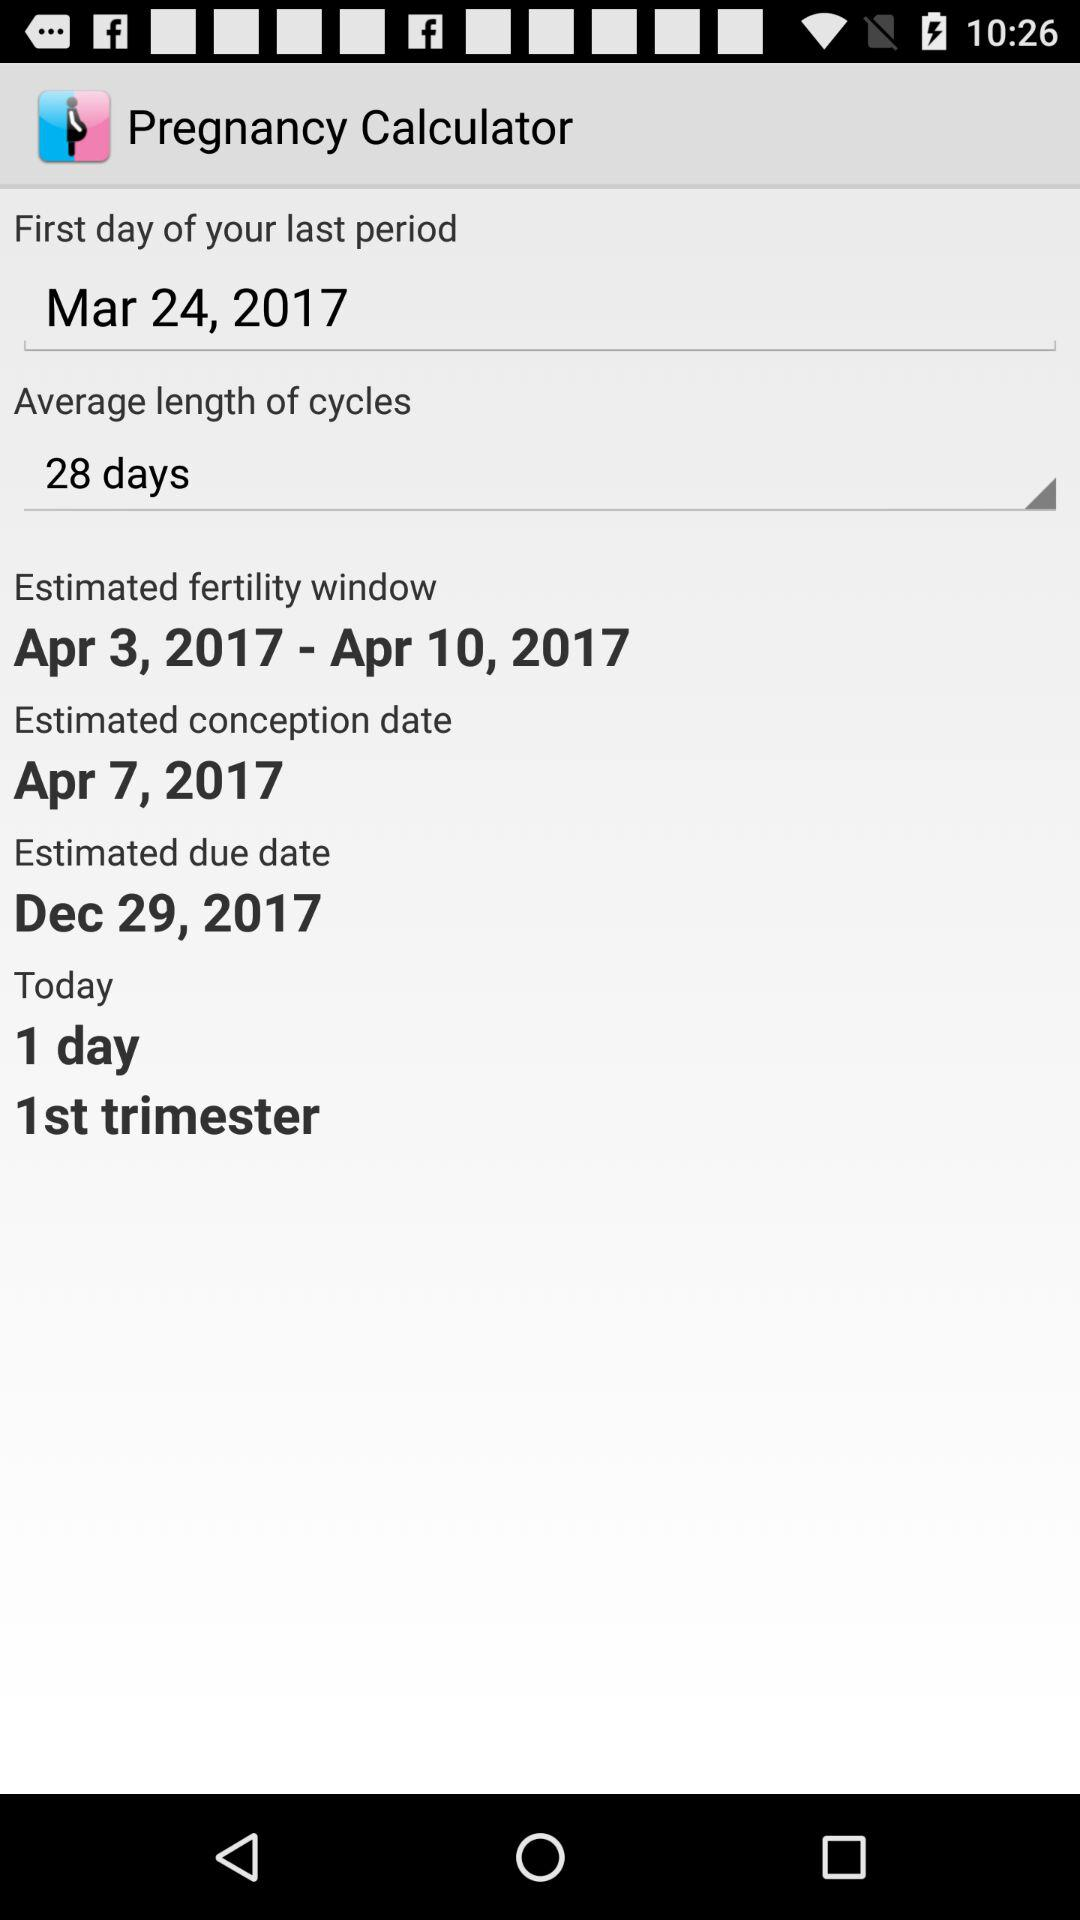What is the "First day of your last period"? The "First day of your last period" is March 24, 2017. 